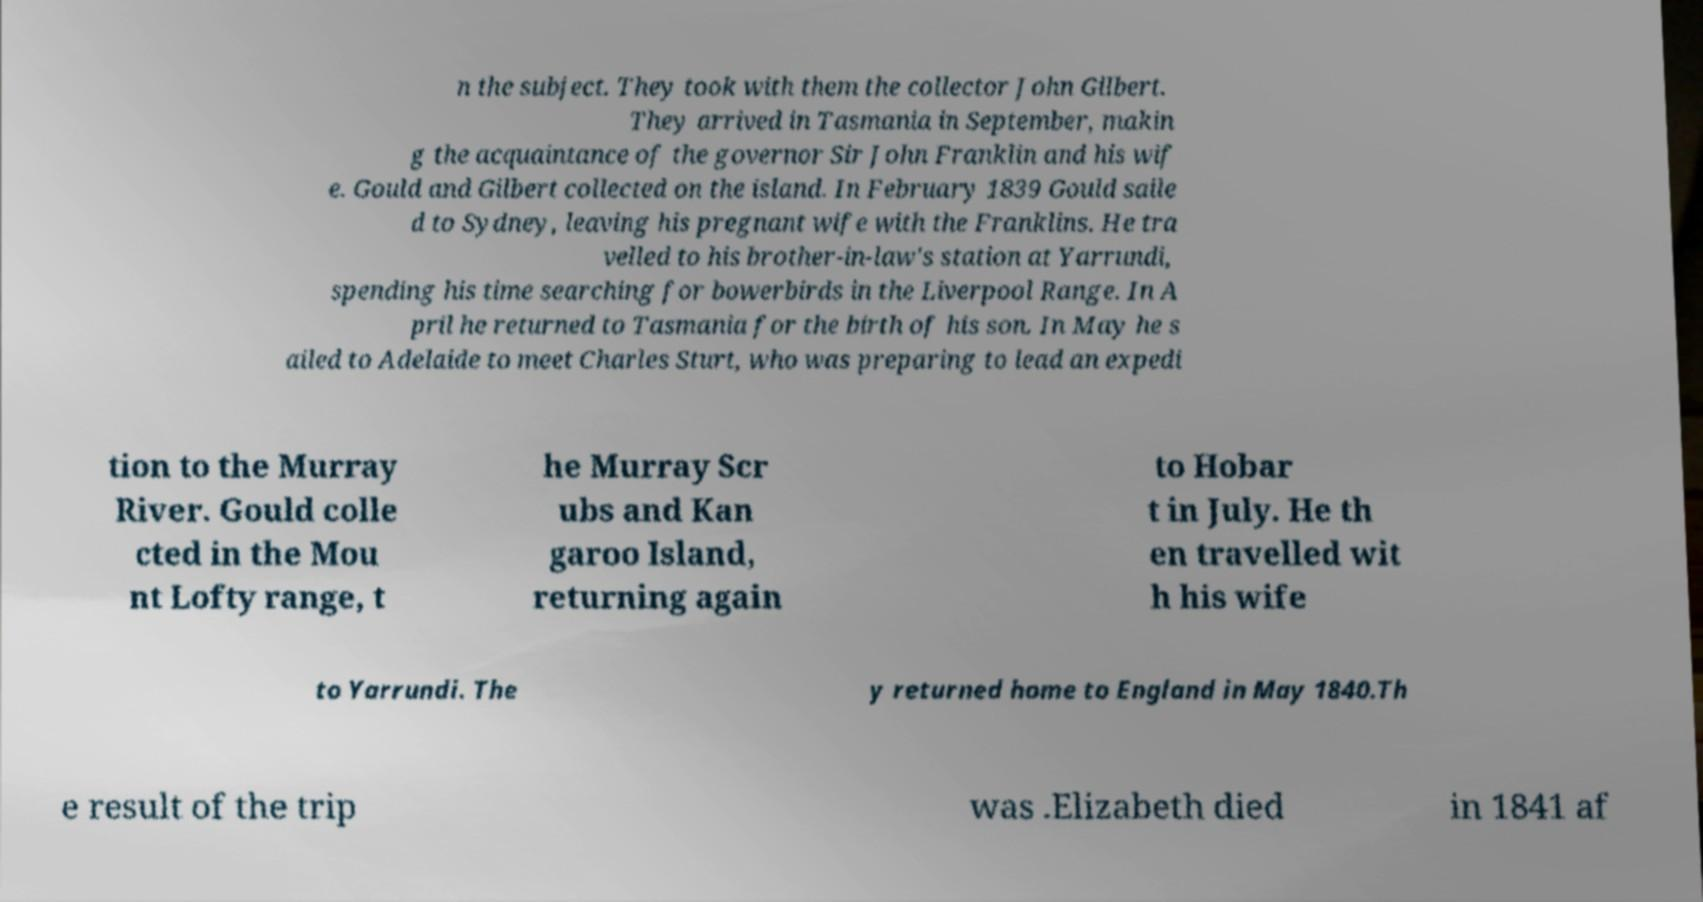Could you assist in decoding the text presented in this image and type it out clearly? n the subject. They took with them the collector John Gilbert. They arrived in Tasmania in September, makin g the acquaintance of the governor Sir John Franklin and his wif e. Gould and Gilbert collected on the island. In February 1839 Gould saile d to Sydney, leaving his pregnant wife with the Franklins. He tra velled to his brother-in-law's station at Yarrundi, spending his time searching for bowerbirds in the Liverpool Range. In A pril he returned to Tasmania for the birth of his son. In May he s ailed to Adelaide to meet Charles Sturt, who was preparing to lead an expedi tion to the Murray River. Gould colle cted in the Mou nt Lofty range, t he Murray Scr ubs and Kan garoo Island, returning again to Hobar t in July. He th en travelled wit h his wife to Yarrundi. The y returned home to England in May 1840.Th e result of the trip was .Elizabeth died in 1841 af 